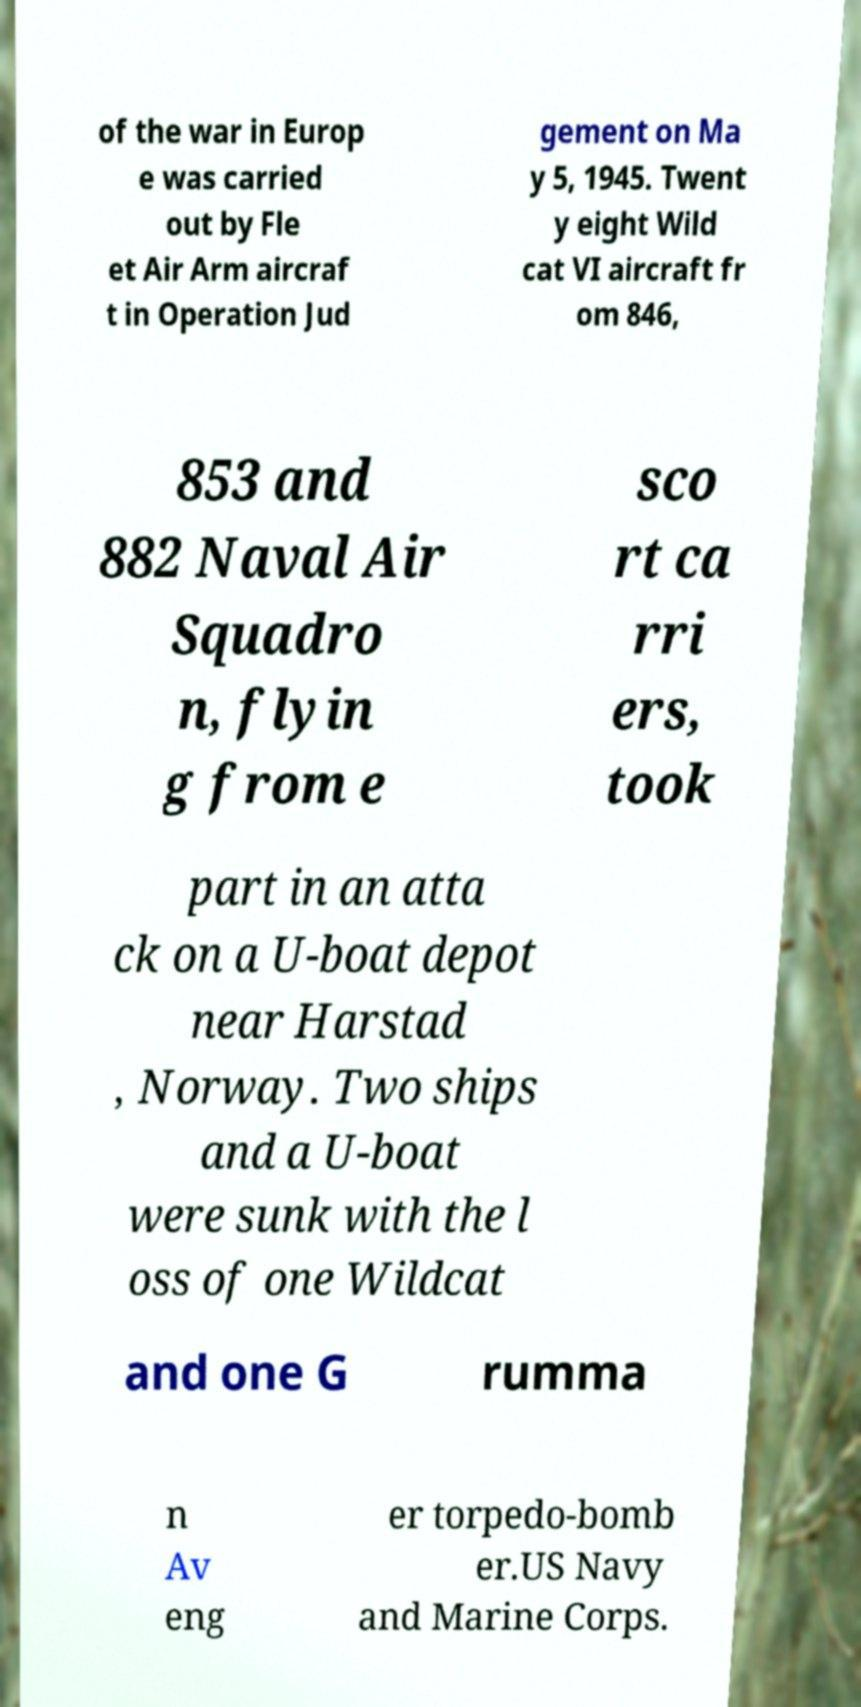Please read and relay the text visible in this image. What does it say? of the war in Europ e was carried out by Fle et Air Arm aircraf t in Operation Jud gement on Ma y 5, 1945. Twent y eight Wild cat VI aircraft fr om 846, 853 and 882 Naval Air Squadro n, flyin g from e sco rt ca rri ers, took part in an atta ck on a U-boat depot near Harstad , Norway. Two ships and a U-boat were sunk with the l oss of one Wildcat and one G rumma n Av eng er torpedo-bomb er.US Navy and Marine Corps. 